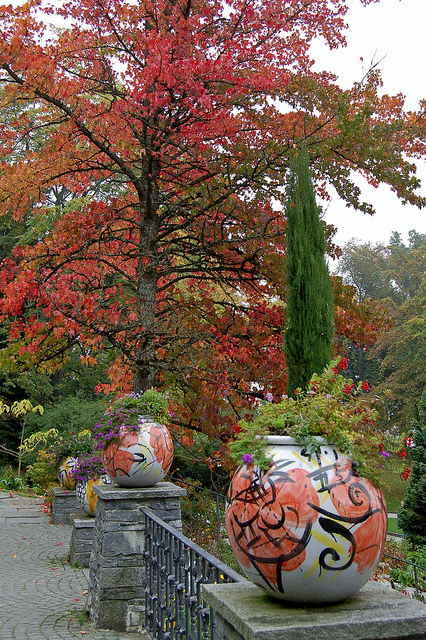<image>How many different trees are in the picture? I don't know how many different trees are in the picture. There could be 6, 5, 4, 3, or 2. How many different trees are in the picture? It is not clear how many different trees are in the picture. It can be seen 2, 4, 5 or 6 different trees. 